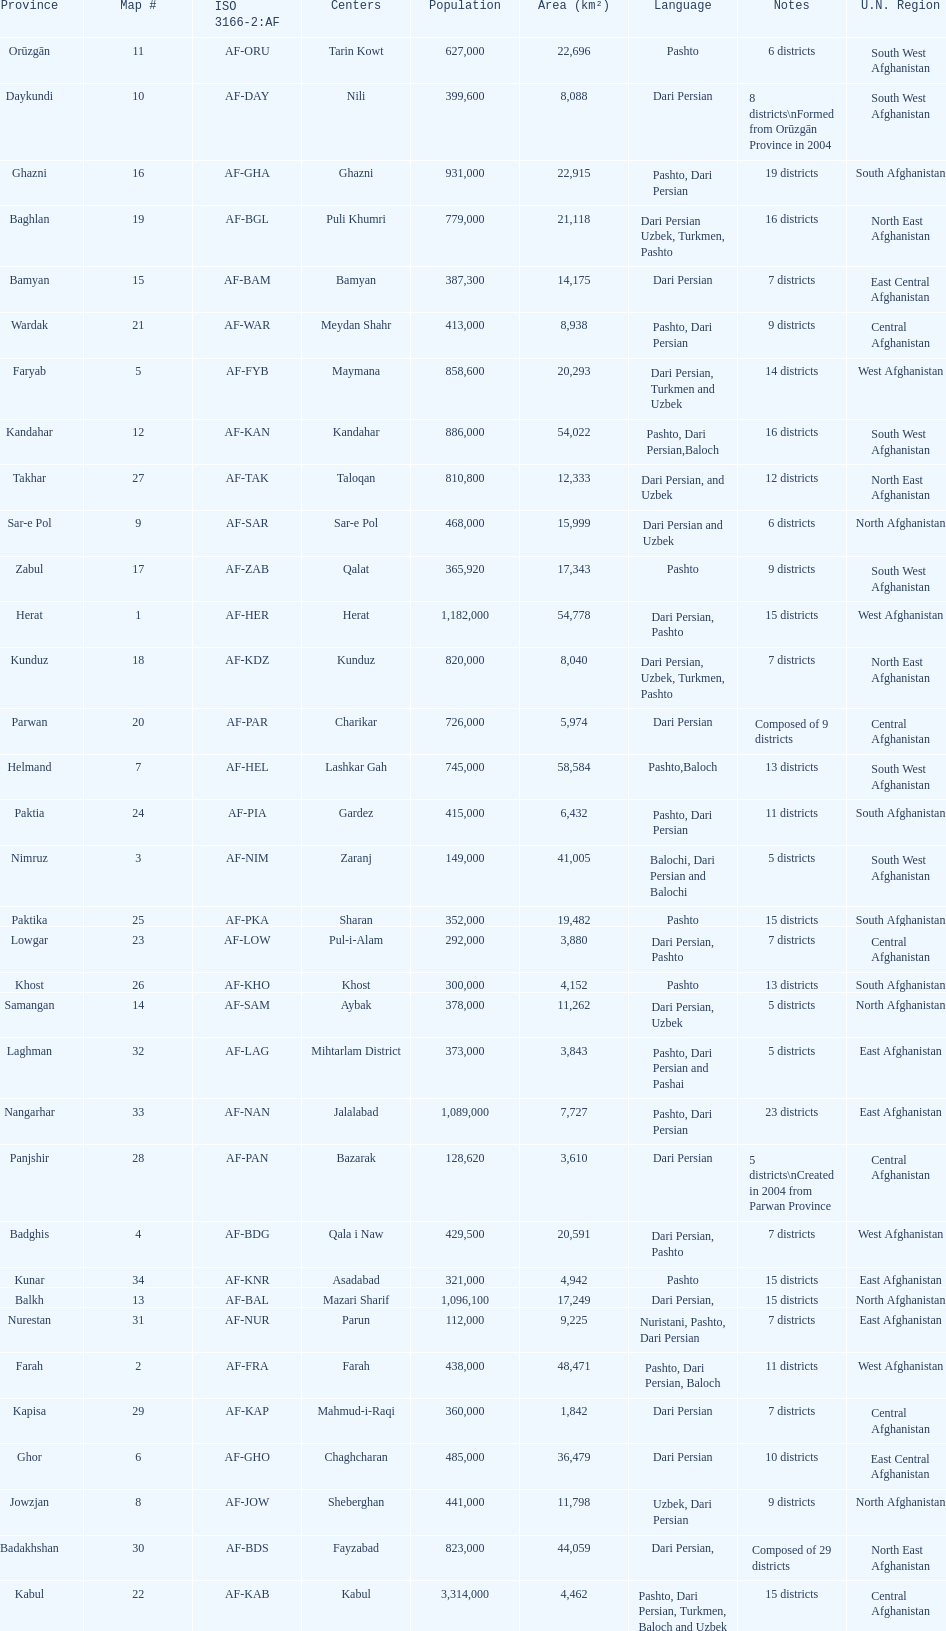How many provinces have pashto as one of their languages 20. 